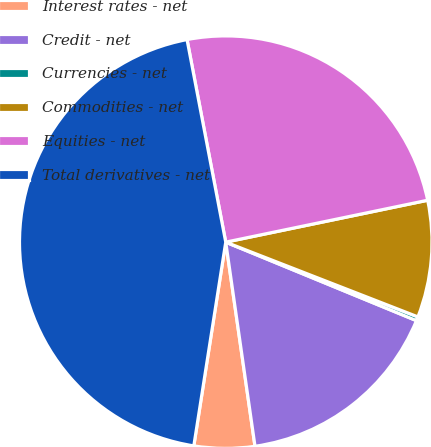<chart> <loc_0><loc_0><loc_500><loc_500><pie_chart><fcel>Interest rates - net<fcel>Credit - net<fcel>Currencies - net<fcel>Commodities - net<fcel>Equities - net<fcel>Total derivatives - net<nl><fcel>4.74%<fcel>16.52%<fcel>0.31%<fcel>9.16%<fcel>24.75%<fcel>44.52%<nl></chart> 